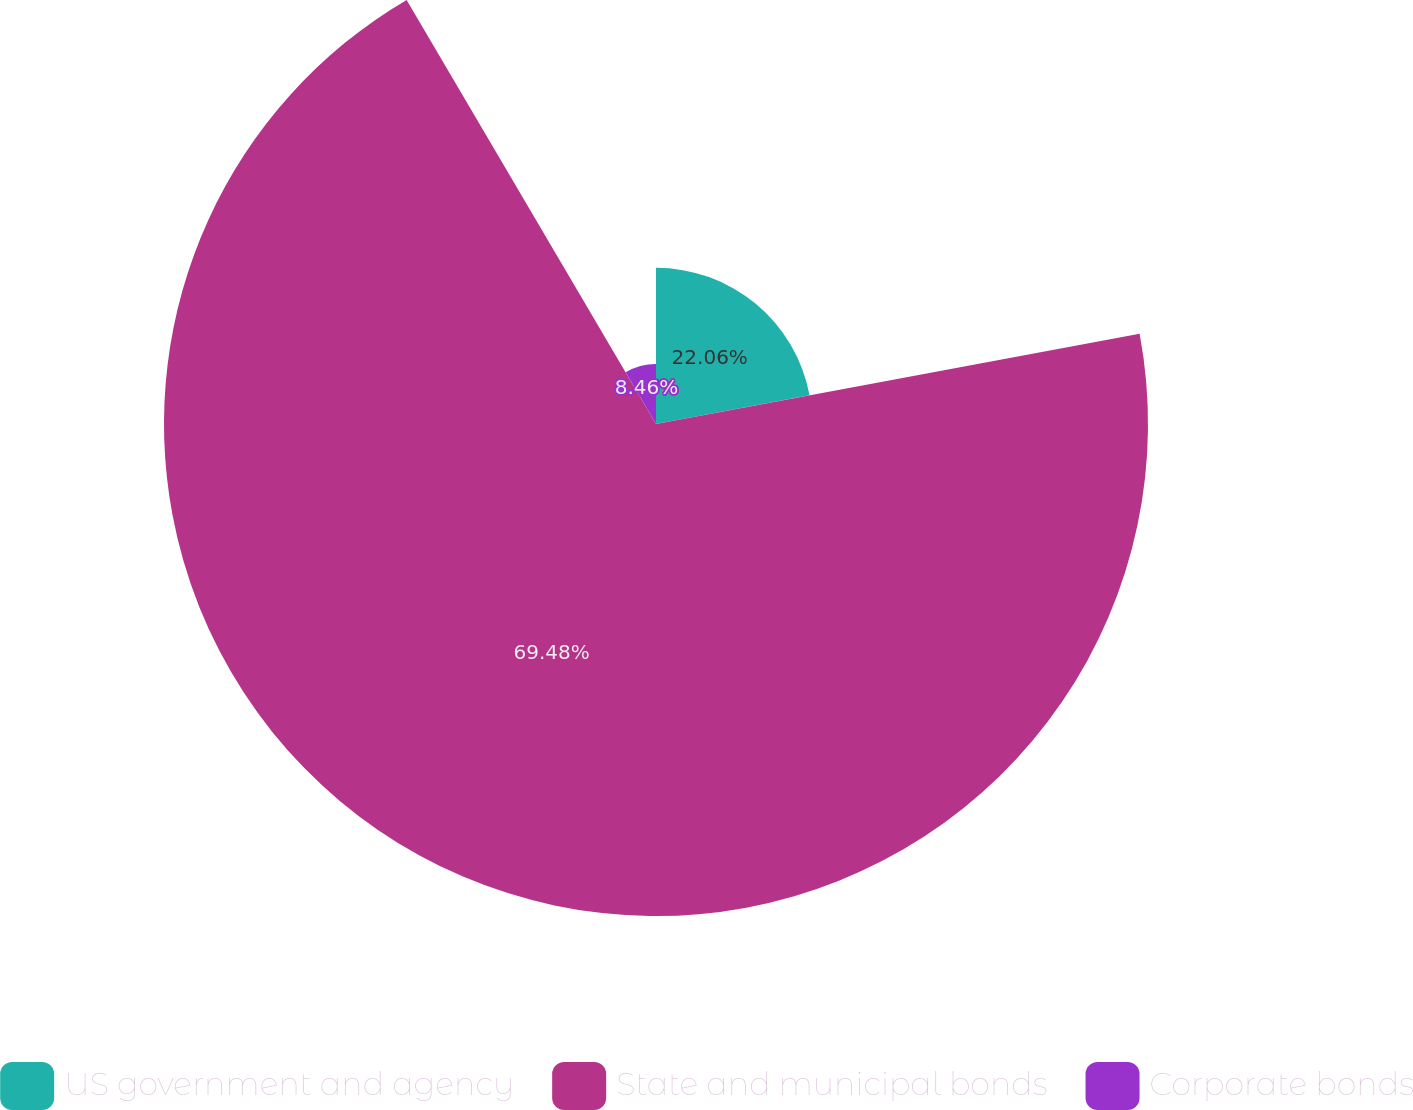Convert chart. <chart><loc_0><loc_0><loc_500><loc_500><pie_chart><fcel>US government and agency<fcel>State and municipal bonds<fcel>Corporate bonds<nl><fcel>22.06%<fcel>69.48%<fcel>8.46%<nl></chart> 